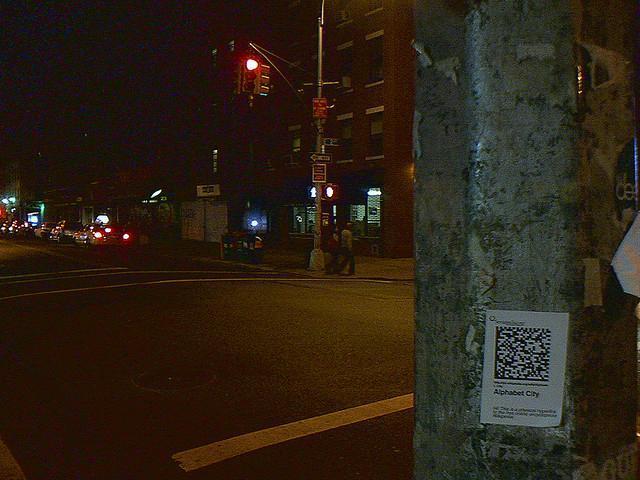How many red suitcases are there in the image?
Give a very brief answer. 0. 